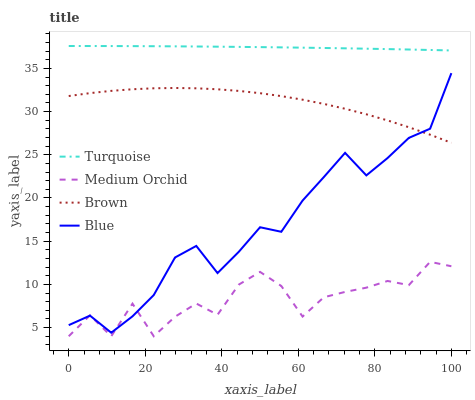Does Medium Orchid have the minimum area under the curve?
Answer yes or no. Yes. Does Turquoise have the maximum area under the curve?
Answer yes or no. Yes. Does Brown have the minimum area under the curve?
Answer yes or no. No. Does Brown have the maximum area under the curve?
Answer yes or no. No. Is Turquoise the smoothest?
Answer yes or no. Yes. Is Medium Orchid the roughest?
Answer yes or no. Yes. Is Brown the smoothest?
Answer yes or no. No. Is Brown the roughest?
Answer yes or no. No. Does Medium Orchid have the lowest value?
Answer yes or no. Yes. Does Brown have the lowest value?
Answer yes or no. No. Does Turquoise have the highest value?
Answer yes or no. Yes. Does Brown have the highest value?
Answer yes or no. No. Is Medium Orchid less than Brown?
Answer yes or no. Yes. Is Turquoise greater than Blue?
Answer yes or no. Yes. Does Blue intersect Medium Orchid?
Answer yes or no. Yes. Is Blue less than Medium Orchid?
Answer yes or no. No. Is Blue greater than Medium Orchid?
Answer yes or no. No. Does Medium Orchid intersect Brown?
Answer yes or no. No. 